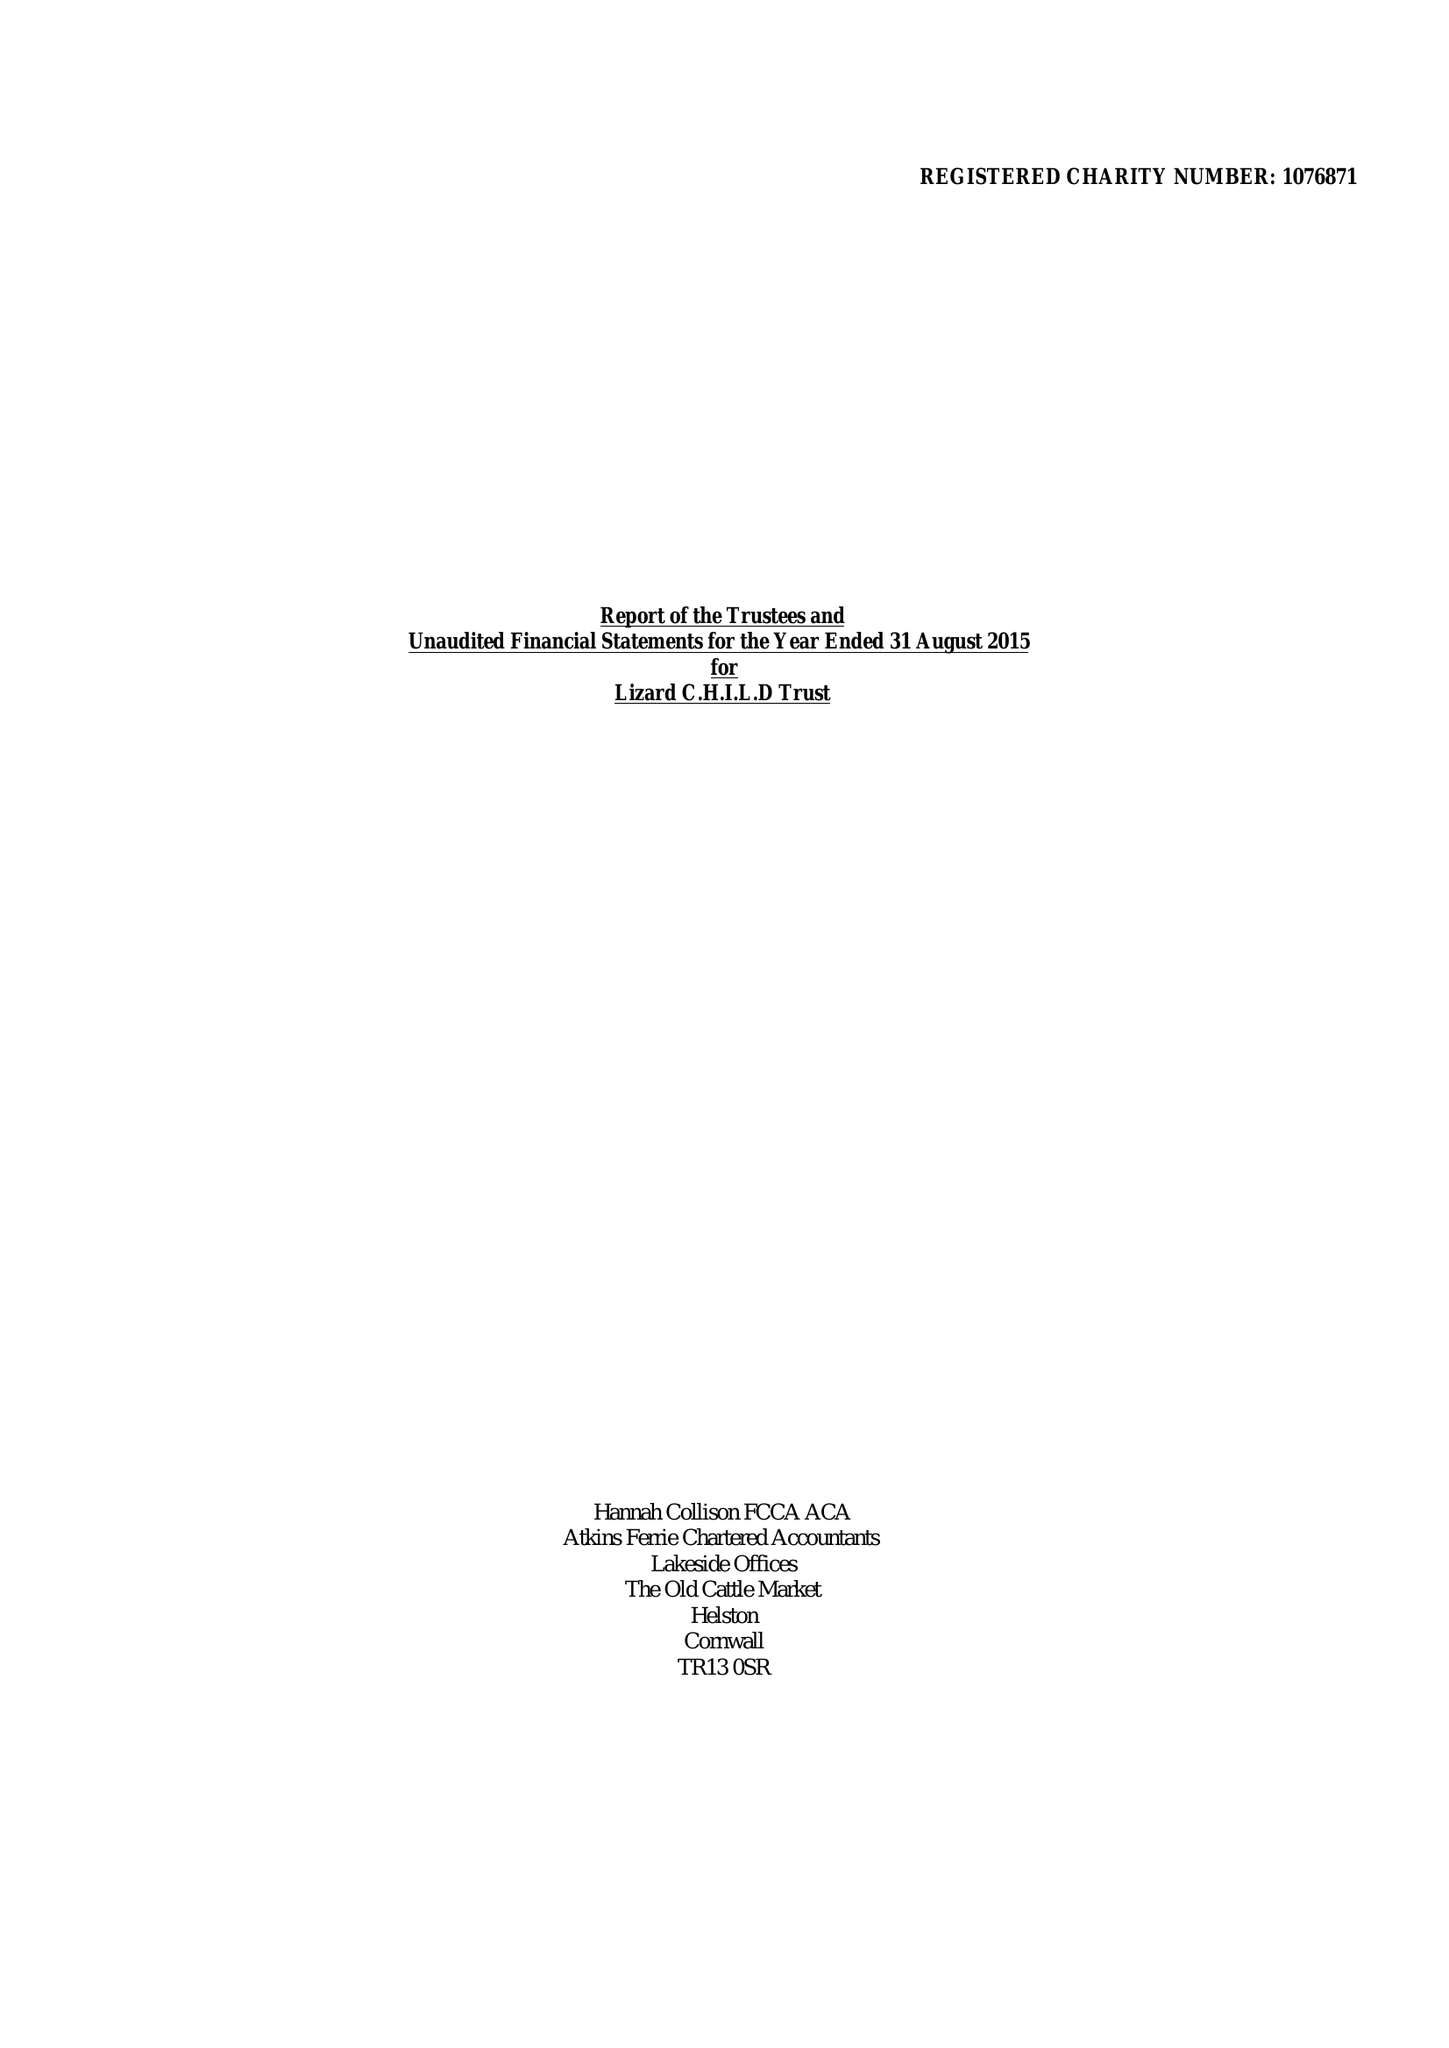What is the value for the address__post_town?
Answer the question using a single word or phrase. HELSTON 